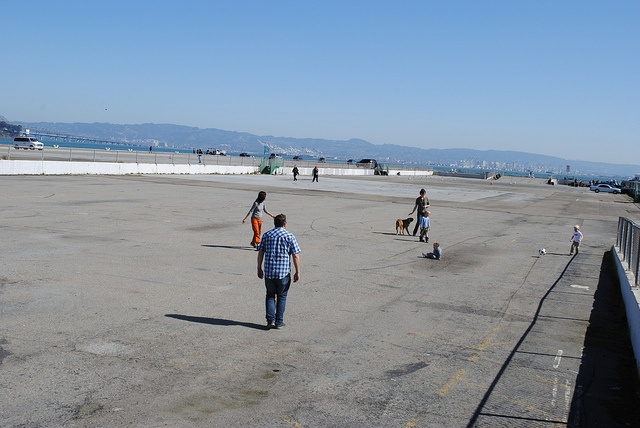Describe the objects in this image and their specific colors. I can see people in darkgray, black, navy, and gray tones, people in darkgray, black, maroon, and gray tones, people in darkgray, black, and gray tones, car in darkgray, gray, and black tones, and people in darkgray, black, and gray tones in this image. 